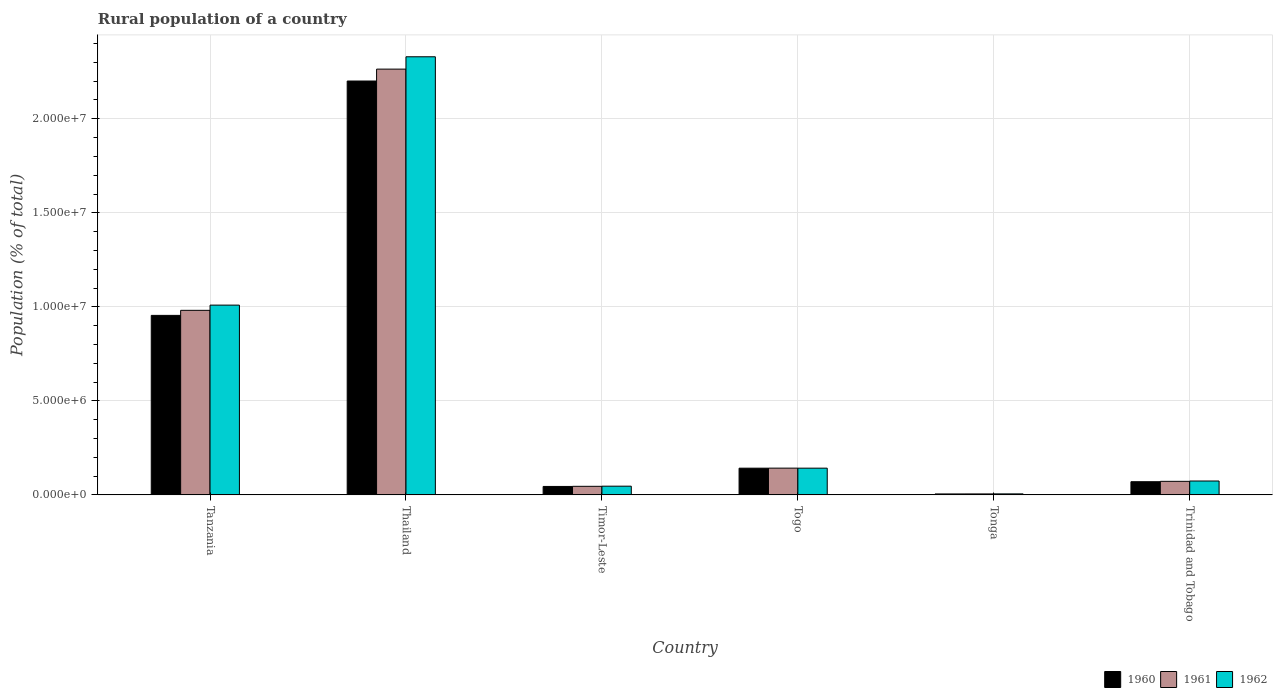How many different coloured bars are there?
Offer a very short reply. 3. How many groups of bars are there?
Provide a short and direct response. 6. Are the number of bars per tick equal to the number of legend labels?
Make the answer very short. Yes. How many bars are there on the 3rd tick from the left?
Offer a very short reply. 3. How many bars are there on the 5th tick from the right?
Give a very brief answer. 3. What is the label of the 1st group of bars from the left?
Provide a short and direct response. Tanzania. In how many cases, is the number of bars for a given country not equal to the number of legend labels?
Your answer should be compact. 0. What is the rural population in 1962 in Tonga?
Keep it short and to the point. 5.41e+04. Across all countries, what is the maximum rural population in 1962?
Offer a terse response. 2.33e+07. Across all countries, what is the minimum rural population in 1962?
Your response must be concise. 5.41e+04. In which country was the rural population in 1960 maximum?
Make the answer very short. Thailand. In which country was the rural population in 1961 minimum?
Your answer should be compact. Tonga. What is the total rural population in 1962 in the graph?
Offer a terse response. 3.61e+07. What is the difference between the rural population in 1962 in Timor-Leste and that in Togo?
Your response must be concise. -9.59e+05. What is the difference between the rural population in 1960 in Trinidad and Tobago and the rural population in 1961 in Tanzania?
Your answer should be compact. -9.11e+06. What is the average rural population in 1962 per country?
Offer a terse response. 6.01e+06. What is the difference between the rural population of/in 1960 and rural population of/in 1962 in Thailand?
Ensure brevity in your answer.  -1.29e+06. In how many countries, is the rural population in 1960 greater than 17000000 %?
Your response must be concise. 1. What is the ratio of the rural population in 1961 in Tanzania to that in Timor-Leste?
Ensure brevity in your answer.  21.51. Is the difference between the rural population in 1960 in Thailand and Timor-Leste greater than the difference between the rural population in 1962 in Thailand and Timor-Leste?
Offer a terse response. No. What is the difference between the highest and the second highest rural population in 1962?
Give a very brief answer. 1.32e+07. What is the difference between the highest and the lowest rural population in 1960?
Your answer should be compact. 2.20e+07. What does the 1st bar from the left in Tanzania represents?
Give a very brief answer. 1960. What does the 1st bar from the right in Tonga represents?
Provide a short and direct response. 1962. Is it the case that in every country, the sum of the rural population in 1962 and rural population in 1960 is greater than the rural population in 1961?
Your response must be concise. Yes. How many bars are there?
Offer a very short reply. 18. Are all the bars in the graph horizontal?
Your answer should be very brief. No. How many countries are there in the graph?
Provide a short and direct response. 6. What is the difference between two consecutive major ticks on the Y-axis?
Your answer should be very brief. 5.00e+06. Are the values on the major ticks of Y-axis written in scientific E-notation?
Your answer should be compact. Yes. Does the graph contain grids?
Your answer should be very brief. Yes. How many legend labels are there?
Make the answer very short. 3. How are the legend labels stacked?
Keep it short and to the point. Horizontal. What is the title of the graph?
Your answer should be compact. Rural population of a country. What is the label or title of the Y-axis?
Offer a very short reply. Population (% of total). What is the Population (% of total) of 1960 in Tanzania?
Your response must be concise. 9.55e+06. What is the Population (% of total) in 1961 in Tanzania?
Give a very brief answer. 9.81e+06. What is the Population (% of total) in 1962 in Tanzania?
Make the answer very short. 1.01e+07. What is the Population (% of total) of 1960 in Thailand?
Keep it short and to the point. 2.20e+07. What is the Population (% of total) in 1961 in Thailand?
Make the answer very short. 2.26e+07. What is the Population (% of total) in 1962 in Thailand?
Offer a very short reply. 2.33e+07. What is the Population (% of total) in 1960 in Timor-Leste?
Your answer should be very brief. 4.49e+05. What is the Population (% of total) of 1961 in Timor-Leste?
Offer a very short reply. 4.56e+05. What is the Population (% of total) of 1962 in Timor-Leste?
Your answer should be very brief. 4.63e+05. What is the Population (% of total) of 1960 in Togo?
Keep it short and to the point. 1.42e+06. What is the Population (% of total) in 1961 in Togo?
Your answer should be compact. 1.42e+06. What is the Population (% of total) of 1962 in Togo?
Offer a terse response. 1.42e+06. What is the Population (% of total) of 1960 in Tonga?
Your response must be concise. 5.08e+04. What is the Population (% of total) of 1961 in Tonga?
Your response must be concise. 5.23e+04. What is the Population (% of total) of 1962 in Tonga?
Your answer should be very brief. 5.41e+04. What is the Population (% of total) in 1960 in Trinidad and Tobago?
Make the answer very short. 7.01e+05. What is the Population (% of total) in 1961 in Trinidad and Tobago?
Your answer should be compact. 7.21e+05. What is the Population (% of total) in 1962 in Trinidad and Tobago?
Offer a terse response. 7.38e+05. Across all countries, what is the maximum Population (% of total) in 1960?
Make the answer very short. 2.20e+07. Across all countries, what is the maximum Population (% of total) of 1961?
Make the answer very short. 2.26e+07. Across all countries, what is the maximum Population (% of total) in 1962?
Provide a short and direct response. 2.33e+07. Across all countries, what is the minimum Population (% of total) in 1960?
Give a very brief answer. 5.08e+04. Across all countries, what is the minimum Population (% of total) of 1961?
Offer a terse response. 5.23e+04. Across all countries, what is the minimum Population (% of total) in 1962?
Your answer should be very brief. 5.41e+04. What is the total Population (% of total) in 1960 in the graph?
Your answer should be compact. 3.42e+07. What is the total Population (% of total) of 1961 in the graph?
Provide a succinct answer. 3.51e+07. What is the total Population (% of total) in 1962 in the graph?
Keep it short and to the point. 3.61e+07. What is the difference between the Population (% of total) of 1960 in Tanzania and that in Thailand?
Your answer should be very brief. -1.25e+07. What is the difference between the Population (% of total) in 1961 in Tanzania and that in Thailand?
Your response must be concise. -1.28e+07. What is the difference between the Population (% of total) in 1962 in Tanzania and that in Thailand?
Provide a succinct answer. -1.32e+07. What is the difference between the Population (% of total) in 1960 in Tanzania and that in Timor-Leste?
Your answer should be very brief. 9.10e+06. What is the difference between the Population (% of total) in 1961 in Tanzania and that in Timor-Leste?
Your response must be concise. 9.36e+06. What is the difference between the Population (% of total) in 1962 in Tanzania and that in Timor-Leste?
Offer a very short reply. 9.63e+06. What is the difference between the Population (% of total) of 1960 in Tanzania and that in Togo?
Provide a succinct answer. 8.13e+06. What is the difference between the Population (% of total) in 1961 in Tanzania and that in Togo?
Provide a succinct answer. 8.39e+06. What is the difference between the Population (% of total) in 1962 in Tanzania and that in Togo?
Keep it short and to the point. 8.67e+06. What is the difference between the Population (% of total) in 1960 in Tanzania and that in Tonga?
Your answer should be very brief. 9.50e+06. What is the difference between the Population (% of total) of 1961 in Tanzania and that in Tonga?
Your answer should be very brief. 9.76e+06. What is the difference between the Population (% of total) of 1962 in Tanzania and that in Tonga?
Your answer should be very brief. 1.00e+07. What is the difference between the Population (% of total) in 1960 in Tanzania and that in Trinidad and Tobago?
Ensure brevity in your answer.  8.84e+06. What is the difference between the Population (% of total) in 1961 in Tanzania and that in Trinidad and Tobago?
Offer a very short reply. 9.09e+06. What is the difference between the Population (% of total) of 1962 in Tanzania and that in Trinidad and Tobago?
Offer a terse response. 9.35e+06. What is the difference between the Population (% of total) in 1960 in Thailand and that in Timor-Leste?
Give a very brief answer. 2.16e+07. What is the difference between the Population (% of total) in 1961 in Thailand and that in Timor-Leste?
Keep it short and to the point. 2.22e+07. What is the difference between the Population (% of total) in 1962 in Thailand and that in Timor-Leste?
Offer a terse response. 2.28e+07. What is the difference between the Population (% of total) of 1960 in Thailand and that in Togo?
Keep it short and to the point. 2.06e+07. What is the difference between the Population (% of total) of 1961 in Thailand and that in Togo?
Offer a very short reply. 2.12e+07. What is the difference between the Population (% of total) in 1962 in Thailand and that in Togo?
Your response must be concise. 2.19e+07. What is the difference between the Population (% of total) in 1960 in Thailand and that in Tonga?
Your answer should be compact. 2.20e+07. What is the difference between the Population (% of total) of 1961 in Thailand and that in Tonga?
Ensure brevity in your answer.  2.26e+07. What is the difference between the Population (% of total) in 1962 in Thailand and that in Tonga?
Your answer should be very brief. 2.32e+07. What is the difference between the Population (% of total) of 1960 in Thailand and that in Trinidad and Tobago?
Keep it short and to the point. 2.13e+07. What is the difference between the Population (% of total) in 1961 in Thailand and that in Trinidad and Tobago?
Ensure brevity in your answer.  2.19e+07. What is the difference between the Population (% of total) in 1962 in Thailand and that in Trinidad and Tobago?
Keep it short and to the point. 2.26e+07. What is the difference between the Population (% of total) of 1960 in Timor-Leste and that in Togo?
Keep it short and to the point. -9.72e+05. What is the difference between the Population (% of total) of 1961 in Timor-Leste and that in Togo?
Ensure brevity in your answer.  -9.67e+05. What is the difference between the Population (% of total) of 1962 in Timor-Leste and that in Togo?
Provide a short and direct response. -9.59e+05. What is the difference between the Population (% of total) in 1960 in Timor-Leste and that in Tonga?
Offer a very short reply. 3.98e+05. What is the difference between the Population (% of total) of 1961 in Timor-Leste and that in Tonga?
Offer a very short reply. 4.04e+05. What is the difference between the Population (% of total) of 1962 in Timor-Leste and that in Tonga?
Offer a very short reply. 4.09e+05. What is the difference between the Population (% of total) of 1960 in Timor-Leste and that in Trinidad and Tobago?
Provide a succinct answer. -2.52e+05. What is the difference between the Population (% of total) of 1961 in Timor-Leste and that in Trinidad and Tobago?
Provide a succinct answer. -2.64e+05. What is the difference between the Population (% of total) of 1962 in Timor-Leste and that in Trinidad and Tobago?
Offer a terse response. -2.75e+05. What is the difference between the Population (% of total) in 1960 in Togo and that in Tonga?
Your answer should be very brief. 1.37e+06. What is the difference between the Population (% of total) in 1961 in Togo and that in Tonga?
Your answer should be very brief. 1.37e+06. What is the difference between the Population (% of total) of 1962 in Togo and that in Tonga?
Your answer should be compact. 1.37e+06. What is the difference between the Population (% of total) in 1960 in Togo and that in Trinidad and Tobago?
Ensure brevity in your answer.  7.20e+05. What is the difference between the Population (% of total) of 1961 in Togo and that in Trinidad and Tobago?
Keep it short and to the point. 7.02e+05. What is the difference between the Population (% of total) of 1962 in Togo and that in Trinidad and Tobago?
Provide a short and direct response. 6.83e+05. What is the difference between the Population (% of total) in 1960 in Tonga and that in Trinidad and Tobago?
Offer a very short reply. -6.50e+05. What is the difference between the Population (% of total) of 1961 in Tonga and that in Trinidad and Tobago?
Your response must be concise. -6.68e+05. What is the difference between the Population (% of total) of 1962 in Tonga and that in Trinidad and Tobago?
Offer a very short reply. -6.84e+05. What is the difference between the Population (% of total) of 1960 in Tanzania and the Population (% of total) of 1961 in Thailand?
Provide a short and direct response. -1.31e+07. What is the difference between the Population (% of total) of 1960 in Tanzania and the Population (% of total) of 1962 in Thailand?
Give a very brief answer. -1.38e+07. What is the difference between the Population (% of total) of 1961 in Tanzania and the Population (% of total) of 1962 in Thailand?
Make the answer very short. -1.35e+07. What is the difference between the Population (% of total) of 1960 in Tanzania and the Population (% of total) of 1961 in Timor-Leste?
Your response must be concise. 9.09e+06. What is the difference between the Population (% of total) of 1960 in Tanzania and the Population (% of total) of 1962 in Timor-Leste?
Offer a terse response. 9.08e+06. What is the difference between the Population (% of total) of 1961 in Tanzania and the Population (% of total) of 1962 in Timor-Leste?
Provide a short and direct response. 9.35e+06. What is the difference between the Population (% of total) of 1960 in Tanzania and the Population (% of total) of 1961 in Togo?
Make the answer very short. 8.12e+06. What is the difference between the Population (% of total) in 1960 in Tanzania and the Population (% of total) in 1962 in Togo?
Give a very brief answer. 8.12e+06. What is the difference between the Population (% of total) in 1961 in Tanzania and the Population (% of total) in 1962 in Togo?
Offer a very short reply. 8.39e+06. What is the difference between the Population (% of total) of 1960 in Tanzania and the Population (% of total) of 1961 in Tonga?
Give a very brief answer. 9.49e+06. What is the difference between the Population (% of total) in 1960 in Tanzania and the Population (% of total) in 1962 in Tonga?
Offer a terse response. 9.49e+06. What is the difference between the Population (% of total) in 1961 in Tanzania and the Population (% of total) in 1962 in Tonga?
Your response must be concise. 9.76e+06. What is the difference between the Population (% of total) in 1960 in Tanzania and the Population (% of total) in 1961 in Trinidad and Tobago?
Ensure brevity in your answer.  8.83e+06. What is the difference between the Population (% of total) of 1960 in Tanzania and the Population (% of total) of 1962 in Trinidad and Tobago?
Provide a short and direct response. 8.81e+06. What is the difference between the Population (% of total) of 1961 in Tanzania and the Population (% of total) of 1962 in Trinidad and Tobago?
Provide a short and direct response. 9.08e+06. What is the difference between the Population (% of total) of 1960 in Thailand and the Population (% of total) of 1961 in Timor-Leste?
Your answer should be compact. 2.16e+07. What is the difference between the Population (% of total) of 1960 in Thailand and the Population (% of total) of 1962 in Timor-Leste?
Your answer should be compact. 2.15e+07. What is the difference between the Population (% of total) of 1961 in Thailand and the Population (% of total) of 1962 in Timor-Leste?
Offer a very short reply. 2.22e+07. What is the difference between the Population (% of total) in 1960 in Thailand and the Population (% of total) in 1961 in Togo?
Make the answer very short. 2.06e+07. What is the difference between the Population (% of total) of 1960 in Thailand and the Population (% of total) of 1962 in Togo?
Your answer should be compact. 2.06e+07. What is the difference between the Population (% of total) of 1961 in Thailand and the Population (% of total) of 1962 in Togo?
Ensure brevity in your answer.  2.12e+07. What is the difference between the Population (% of total) in 1960 in Thailand and the Population (% of total) in 1961 in Tonga?
Your answer should be compact. 2.20e+07. What is the difference between the Population (% of total) in 1960 in Thailand and the Population (% of total) in 1962 in Tonga?
Offer a very short reply. 2.20e+07. What is the difference between the Population (% of total) of 1961 in Thailand and the Population (% of total) of 1962 in Tonga?
Give a very brief answer. 2.26e+07. What is the difference between the Population (% of total) in 1960 in Thailand and the Population (% of total) in 1961 in Trinidad and Tobago?
Provide a short and direct response. 2.13e+07. What is the difference between the Population (% of total) of 1960 in Thailand and the Population (% of total) of 1962 in Trinidad and Tobago?
Make the answer very short. 2.13e+07. What is the difference between the Population (% of total) in 1961 in Thailand and the Population (% of total) in 1962 in Trinidad and Tobago?
Provide a succinct answer. 2.19e+07. What is the difference between the Population (% of total) in 1960 in Timor-Leste and the Population (% of total) in 1961 in Togo?
Your answer should be compact. -9.74e+05. What is the difference between the Population (% of total) of 1960 in Timor-Leste and the Population (% of total) of 1962 in Togo?
Offer a terse response. -9.73e+05. What is the difference between the Population (% of total) in 1961 in Timor-Leste and the Population (% of total) in 1962 in Togo?
Provide a succinct answer. -9.65e+05. What is the difference between the Population (% of total) of 1960 in Timor-Leste and the Population (% of total) of 1961 in Tonga?
Provide a succinct answer. 3.97e+05. What is the difference between the Population (% of total) in 1960 in Timor-Leste and the Population (% of total) in 1962 in Tonga?
Your answer should be very brief. 3.95e+05. What is the difference between the Population (% of total) in 1961 in Timor-Leste and the Population (% of total) in 1962 in Tonga?
Provide a succinct answer. 4.02e+05. What is the difference between the Population (% of total) in 1960 in Timor-Leste and the Population (% of total) in 1961 in Trinidad and Tobago?
Keep it short and to the point. -2.72e+05. What is the difference between the Population (% of total) of 1960 in Timor-Leste and the Population (% of total) of 1962 in Trinidad and Tobago?
Offer a terse response. -2.89e+05. What is the difference between the Population (% of total) in 1961 in Timor-Leste and the Population (% of total) in 1962 in Trinidad and Tobago?
Ensure brevity in your answer.  -2.82e+05. What is the difference between the Population (% of total) in 1960 in Togo and the Population (% of total) in 1961 in Tonga?
Keep it short and to the point. 1.37e+06. What is the difference between the Population (% of total) in 1960 in Togo and the Population (% of total) in 1962 in Tonga?
Give a very brief answer. 1.37e+06. What is the difference between the Population (% of total) in 1961 in Togo and the Population (% of total) in 1962 in Tonga?
Keep it short and to the point. 1.37e+06. What is the difference between the Population (% of total) of 1960 in Togo and the Population (% of total) of 1961 in Trinidad and Tobago?
Your answer should be very brief. 7.00e+05. What is the difference between the Population (% of total) of 1960 in Togo and the Population (% of total) of 1962 in Trinidad and Tobago?
Your answer should be very brief. 6.83e+05. What is the difference between the Population (% of total) of 1961 in Togo and the Population (% of total) of 1962 in Trinidad and Tobago?
Your answer should be compact. 6.84e+05. What is the difference between the Population (% of total) of 1960 in Tonga and the Population (% of total) of 1961 in Trinidad and Tobago?
Offer a terse response. -6.70e+05. What is the difference between the Population (% of total) of 1960 in Tonga and the Population (% of total) of 1962 in Trinidad and Tobago?
Provide a short and direct response. -6.88e+05. What is the difference between the Population (% of total) of 1961 in Tonga and the Population (% of total) of 1962 in Trinidad and Tobago?
Provide a short and direct response. -6.86e+05. What is the average Population (% of total) in 1960 per country?
Ensure brevity in your answer.  5.70e+06. What is the average Population (% of total) of 1961 per country?
Your response must be concise. 5.85e+06. What is the average Population (% of total) in 1962 per country?
Provide a succinct answer. 6.01e+06. What is the difference between the Population (% of total) in 1960 and Population (% of total) in 1961 in Tanzania?
Provide a succinct answer. -2.68e+05. What is the difference between the Population (% of total) of 1960 and Population (% of total) of 1962 in Tanzania?
Your answer should be very brief. -5.45e+05. What is the difference between the Population (% of total) of 1961 and Population (% of total) of 1962 in Tanzania?
Your response must be concise. -2.77e+05. What is the difference between the Population (% of total) in 1960 and Population (% of total) in 1961 in Thailand?
Your answer should be very brief. -6.34e+05. What is the difference between the Population (% of total) in 1960 and Population (% of total) in 1962 in Thailand?
Your answer should be very brief. -1.29e+06. What is the difference between the Population (% of total) of 1961 and Population (% of total) of 1962 in Thailand?
Your answer should be very brief. -6.56e+05. What is the difference between the Population (% of total) in 1960 and Population (% of total) in 1961 in Timor-Leste?
Provide a succinct answer. -7127. What is the difference between the Population (% of total) of 1960 and Population (% of total) of 1962 in Timor-Leste?
Keep it short and to the point. -1.39e+04. What is the difference between the Population (% of total) in 1961 and Population (% of total) in 1962 in Timor-Leste?
Offer a very short reply. -6812. What is the difference between the Population (% of total) of 1960 and Population (% of total) of 1961 in Togo?
Give a very brief answer. -1845. What is the difference between the Population (% of total) in 1960 and Population (% of total) in 1962 in Togo?
Your response must be concise. -830. What is the difference between the Population (% of total) of 1961 and Population (% of total) of 1962 in Togo?
Your answer should be very brief. 1015. What is the difference between the Population (% of total) in 1960 and Population (% of total) in 1961 in Tonga?
Your answer should be very brief. -1524. What is the difference between the Population (% of total) in 1960 and Population (% of total) in 1962 in Tonga?
Give a very brief answer. -3334. What is the difference between the Population (% of total) in 1961 and Population (% of total) in 1962 in Tonga?
Keep it short and to the point. -1810. What is the difference between the Population (% of total) of 1960 and Population (% of total) of 1961 in Trinidad and Tobago?
Provide a succinct answer. -1.95e+04. What is the difference between the Population (% of total) of 1960 and Population (% of total) of 1962 in Trinidad and Tobago?
Offer a very short reply. -3.71e+04. What is the difference between the Population (% of total) in 1961 and Population (% of total) in 1962 in Trinidad and Tobago?
Offer a very short reply. -1.77e+04. What is the ratio of the Population (% of total) of 1960 in Tanzania to that in Thailand?
Ensure brevity in your answer.  0.43. What is the ratio of the Population (% of total) in 1961 in Tanzania to that in Thailand?
Ensure brevity in your answer.  0.43. What is the ratio of the Population (% of total) in 1962 in Tanzania to that in Thailand?
Provide a succinct answer. 0.43. What is the ratio of the Population (% of total) of 1960 in Tanzania to that in Timor-Leste?
Provide a short and direct response. 21.25. What is the ratio of the Population (% of total) of 1961 in Tanzania to that in Timor-Leste?
Keep it short and to the point. 21.51. What is the ratio of the Population (% of total) in 1962 in Tanzania to that in Timor-Leste?
Your answer should be compact. 21.79. What is the ratio of the Population (% of total) of 1960 in Tanzania to that in Togo?
Your response must be concise. 6.72. What is the ratio of the Population (% of total) of 1961 in Tanzania to that in Togo?
Give a very brief answer. 6.9. What is the ratio of the Population (% of total) of 1962 in Tanzania to that in Togo?
Give a very brief answer. 7.1. What is the ratio of the Population (% of total) in 1960 in Tanzania to that in Tonga?
Provide a succinct answer. 187.96. What is the ratio of the Population (% of total) in 1961 in Tanzania to that in Tonga?
Your response must be concise. 187.6. What is the ratio of the Population (% of total) in 1962 in Tanzania to that in Tonga?
Your response must be concise. 186.45. What is the ratio of the Population (% of total) in 1960 in Tanzania to that in Trinidad and Tobago?
Give a very brief answer. 13.61. What is the ratio of the Population (% of total) in 1961 in Tanzania to that in Trinidad and Tobago?
Your response must be concise. 13.62. What is the ratio of the Population (% of total) of 1962 in Tanzania to that in Trinidad and Tobago?
Your response must be concise. 13.67. What is the ratio of the Population (% of total) of 1960 in Thailand to that in Timor-Leste?
Offer a very short reply. 49. What is the ratio of the Population (% of total) of 1961 in Thailand to that in Timor-Leste?
Ensure brevity in your answer.  49.62. What is the ratio of the Population (% of total) of 1962 in Thailand to that in Timor-Leste?
Provide a short and direct response. 50.31. What is the ratio of the Population (% of total) of 1960 in Thailand to that in Togo?
Offer a terse response. 15.49. What is the ratio of the Population (% of total) in 1961 in Thailand to that in Togo?
Make the answer very short. 15.91. What is the ratio of the Population (% of total) of 1962 in Thailand to that in Togo?
Ensure brevity in your answer.  16.39. What is the ratio of the Population (% of total) in 1960 in Thailand to that in Tonga?
Offer a terse response. 433.32. What is the ratio of the Population (% of total) of 1961 in Thailand to that in Tonga?
Your answer should be very brief. 432.81. What is the ratio of the Population (% of total) in 1962 in Thailand to that in Tonga?
Your answer should be compact. 430.45. What is the ratio of the Population (% of total) in 1960 in Thailand to that in Trinidad and Tobago?
Offer a very short reply. 31.38. What is the ratio of the Population (% of total) in 1961 in Thailand to that in Trinidad and Tobago?
Provide a short and direct response. 31.41. What is the ratio of the Population (% of total) of 1962 in Thailand to that in Trinidad and Tobago?
Offer a terse response. 31.55. What is the ratio of the Population (% of total) in 1960 in Timor-Leste to that in Togo?
Make the answer very short. 0.32. What is the ratio of the Population (% of total) of 1961 in Timor-Leste to that in Togo?
Make the answer very short. 0.32. What is the ratio of the Population (% of total) in 1962 in Timor-Leste to that in Togo?
Provide a short and direct response. 0.33. What is the ratio of the Population (% of total) of 1960 in Timor-Leste to that in Tonga?
Give a very brief answer. 8.84. What is the ratio of the Population (% of total) in 1961 in Timor-Leste to that in Tonga?
Provide a succinct answer. 8.72. What is the ratio of the Population (% of total) in 1962 in Timor-Leste to that in Tonga?
Provide a succinct answer. 8.56. What is the ratio of the Population (% of total) of 1960 in Timor-Leste to that in Trinidad and Tobago?
Provide a short and direct response. 0.64. What is the ratio of the Population (% of total) in 1961 in Timor-Leste to that in Trinidad and Tobago?
Your answer should be very brief. 0.63. What is the ratio of the Population (% of total) of 1962 in Timor-Leste to that in Trinidad and Tobago?
Provide a short and direct response. 0.63. What is the ratio of the Population (% of total) in 1960 in Togo to that in Tonga?
Ensure brevity in your answer.  27.98. What is the ratio of the Population (% of total) in 1961 in Togo to that in Tonga?
Your answer should be compact. 27.2. What is the ratio of the Population (% of total) in 1962 in Togo to that in Tonga?
Give a very brief answer. 26.27. What is the ratio of the Population (% of total) in 1960 in Togo to that in Trinidad and Tobago?
Your answer should be compact. 2.03. What is the ratio of the Population (% of total) in 1961 in Togo to that in Trinidad and Tobago?
Offer a very short reply. 1.97. What is the ratio of the Population (% of total) of 1962 in Togo to that in Trinidad and Tobago?
Your response must be concise. 1.93. What is the ratio of the Population (% of total) in 1960 in Tonga to that in Trinidad and Tobago?
Offer a very short reply. 0.07. What is the ratio of the Population (% of total) of 1961 in Tonga to that in Trinidad and Tobago?
Offer a very short reply. 0.07. What is the ratio of the Population (% of total) of 1962 in Tonga to that in Trinidad and Tobago?
Keep it short and to the point. 0.07. What is the difference between the highest and the second highest Population (% of total) in 1960?
Give a very brief answer. 1.25e+07. What is the difference between the highest and the second highest Population (% of total) of 1961?
Make the answer very short. 1.28e+07. What is the difference between the highest and the second highest Population (% of total) of 1962?
Your answer should be compact. 1.32e+07. What is the difference between the highest and the lowest Population (% of total) of 1960?
Provide a short and direct response. 2.20e+07. What is the difference between the highest and the lowest Population (% of total) in 1961?
Offer a terse response. 2.26e+07. What is the difference between the highest and the lowest Population (% of total) in 1962?
Your response must be concise. 2.32e+07. 